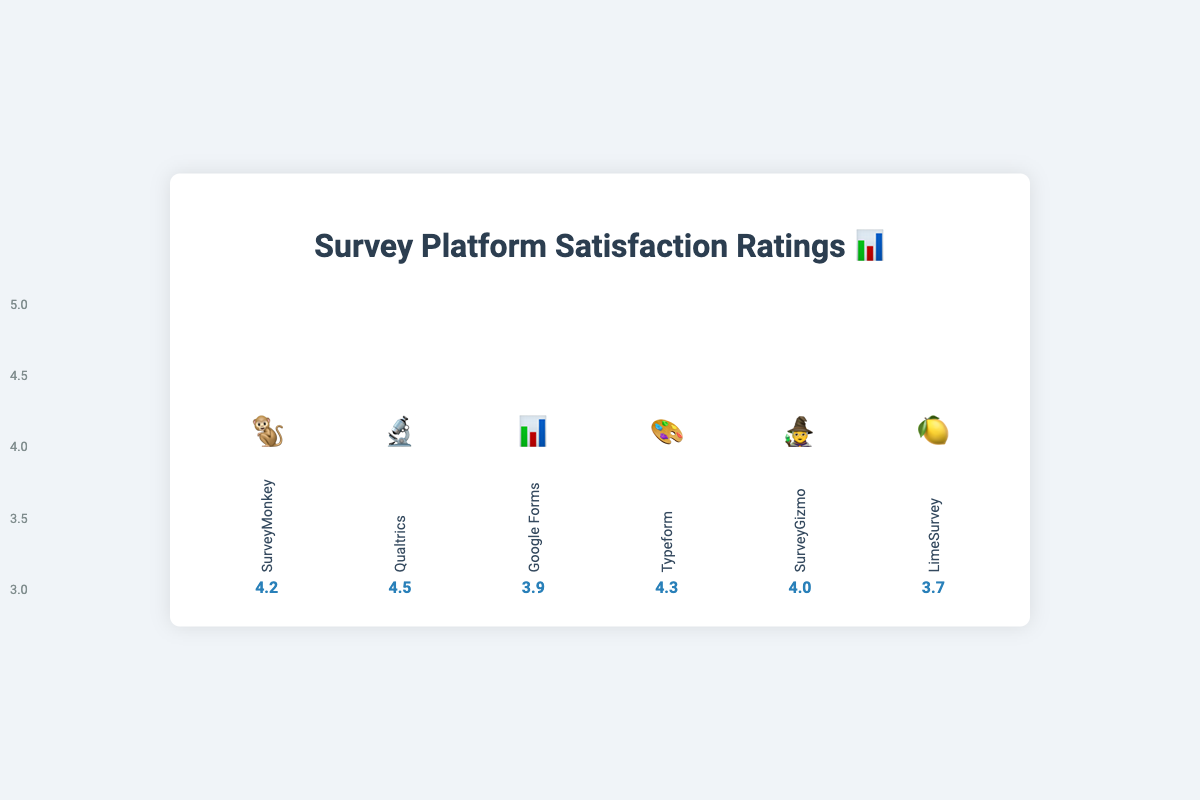What is the highest customer satisfaction rating, and which platform received it? The platform with the highest satisfaction rating can be identified by observing the bars for each platform. The tallest bar corresponds to the highest rating. According to the figure, Qualtrics has the highest customer satisfaction rating of 4.5.
Answer: 4.5, Qualtrics Which survey platform has the lowest satisfaction rating, and what is that rating? To find the lowest satisfaction rating, look for the shortest bar. The shortest bar belongs to LimeSurvey, which has a satisfaction rating of 3.7.
Answer: LimeSurvey, 3.7 How does the satisfaction rating of Google Forms compare to SurveyGizmo? To compare the ratings of Google Forms and SurveyGizmo, observe the heights of their respective bars. Google Forms has a satisfaction rating of 3.9, while SurveyGizmo has a rating of 4.0. Thus, SurveyGizmo has a higher satisfaction rating than Google Forms.
Answer: SurveyGizmo is higher than Google Forms What is the average satisfaction rating of all survey platforms combined? To find the average, sum up the satisfaction ratings of all platforms: (4.2 + 4.5 + 3.9 + 4.3 + 4.0 + 3.7) = 24.6. Now divide by the number of platforms, which is 6. The average satisfaction rating is 24.6 / 6 = 4.1.
Answer: 4.1 What's the difference in satisfaction rating between SurveyMonkey and Typeform? To find the difference, subtract the satisfaction rating of SurveyMonkey from Typeform: 4.3 (Typeform) - 4.2 (SurveyMonkey) = 0.1.
Answer: 0.1 If we only consider platforms with a satisfaction rating greater than 4.0, which platforms qualify? By checking the ratings, platforms with ratings greater than 4.0 are SurveyMonkey (4.2), Qualtrics (4.5), and Typeform (4.3).
Answer: SurveyMonkey, Qualtrics, Typeform What is the total combined height percentage of the bars for SurveyMonkey and Google Forms? The height for SurveyMonkey is 84%, and for Google Forms, it is 78%. Adding these percentages gives 84% + 78% = 162%.
Answer: 162% Which platform has a satisfaction rating that is closest to the average rating of all platforms? First, we calculate the average rating as 4.1. Now, comparing how close each platform's rating is to 4.1, we find that SurveyMonkey's rating of 4.2 is closest to the average.
Answer: SurveyMonkey Among SurveyGizmo and LimeSurvey, which platform has a higher satisfaction rating, and by how much? SurveyGizmo has a rating of 4.0, while LimeSurvey has a rating of 3.7. The difference in their ratings is 4.0 - 3.7 = 0.3.
Answer: SurveyGizmo, 0.3 